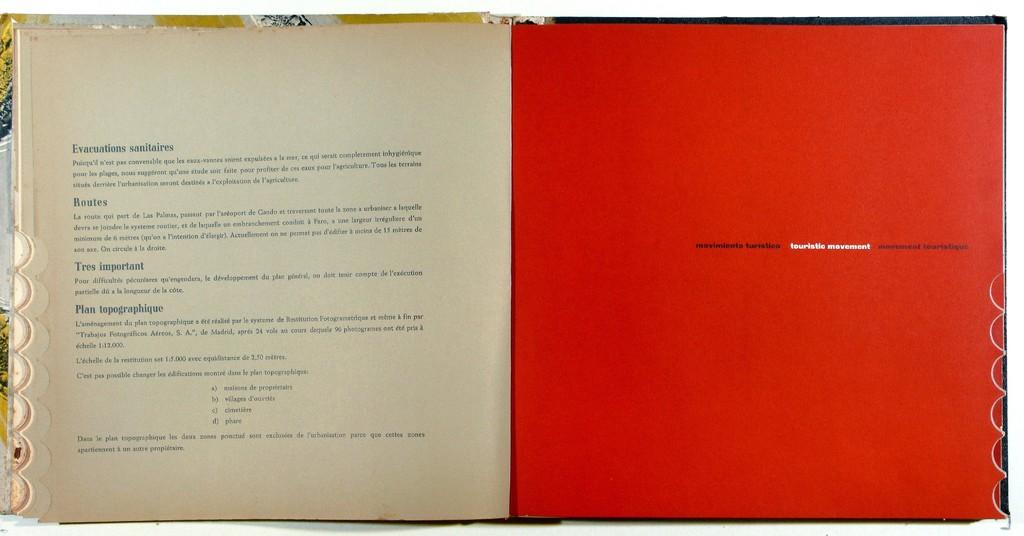<image>
Relay a brief, clear account of the picture shown. A book opened to the page that reads Evacuations Sanitaries. 